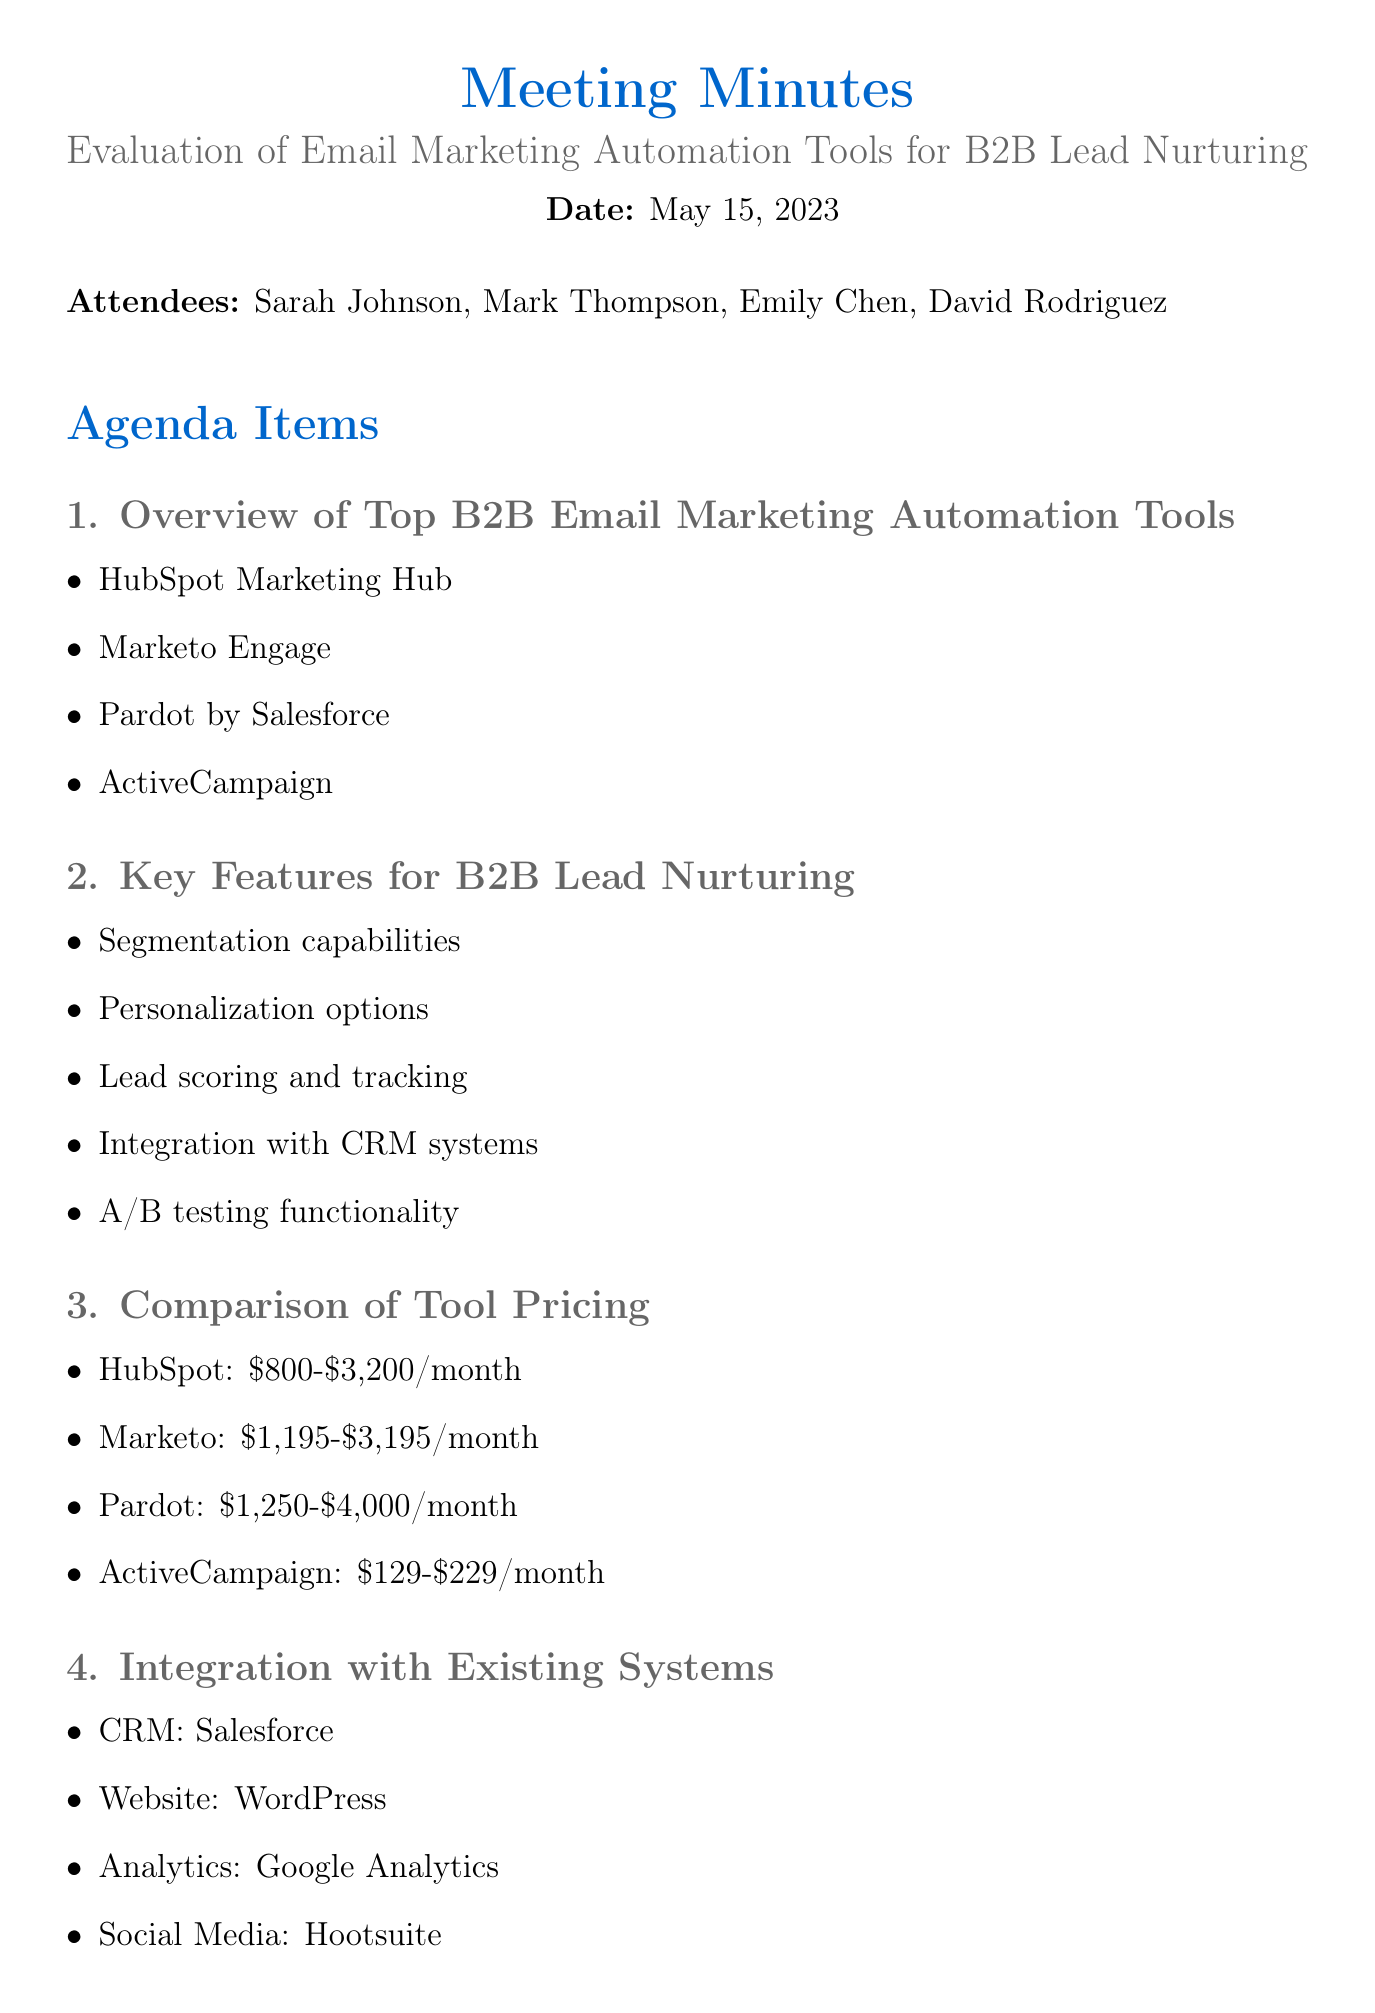What is the date of the meeting? The date is explicitly stated at the beginning of the document.
Answer: May 15, 2023 Who scheduled demos with HubSpot and Marketo? The action item mentions the person assigned to this task.
Answer: Sarah Johnson What are the two email marketing automation tools mentioned for demos? The agenda items specify the tools to be demonstrated.
Answer: HubSpot and Marketo What is the price range of Pardot? The pricing comparison in the document lists this information.
Answer: $1,250-$4,000/month Which system is listed as the CRM for integration? The integration section identifies the CRM used.
Answer: Salesforce Which feature involves testing different email versions? The key features section includes this specific functionality.
Answer: A/B testing functionality What is the due date for the budget proposal preparation? The action items include specific due dates for each task.
Answer: May 29, 2023 What is the primary purpose of the discussed tools? The context of the meeting is focused on B2B marketing needs.
Answer: Lead nurturing Who is responsible for drafting initial lead nurturing campaign ideas? The action items specify who is tasked with this responsibility.
Answer: Mark Thompson 